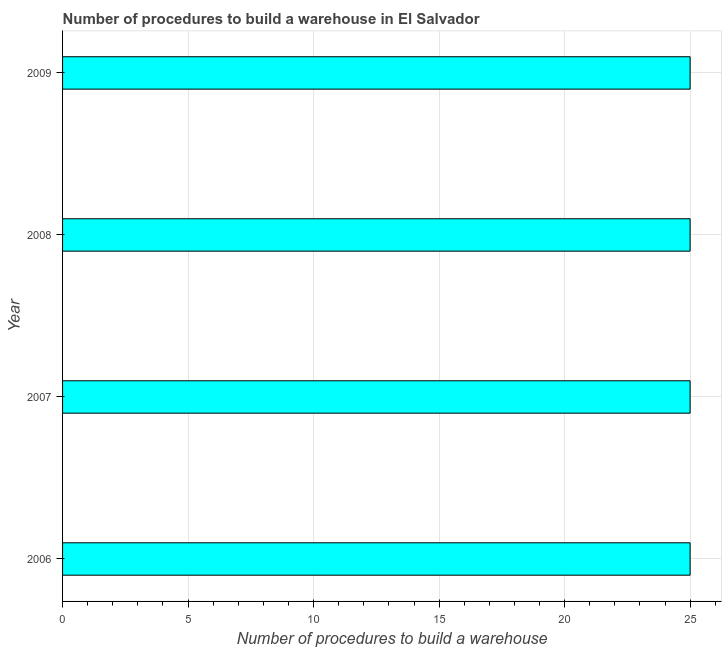Does the graph contain grids?
Your response must be concise. Yes. What is the title of the graph?
Give a very brief answer. Number of procedures to build a warehouse in El Salvador. What is the label or title of the X-axis?
Your response must be concise. Number of procedures to build a warehouse. What is the label or title of the Y-axis?
Offer a very short reply. Year. In which year was the number of procedures to build a warehouse maximum?
Your response must be concise. 2006. In which year was the number of procedures to build a warehouse minimum?
Provide a short and direct response. 2006. Do a majority of the years between 2006 and 2007 (inclusive) have number of procedures to build a warehouse greater than 19 ?
Offer a very short reply. Yes. Is the number of procedures to build a warehouse in 2008 less than that in 2009?
Provide a succinct answer. No. Is the difference between the number of procedures to build a warehouse in 2007 and 2009 greater than the difference between any two years?
Keep it short and to the point. Yes. Is the sum of the number of procedures to build a warehouse in 2006 and 2007 greater than the maximum number of procedures to build a warehouse across all years?
Offer a terse response. Yes. Are all the bars in the graph horizontal?
Provide a short and direct response. Yes. How many years are there in the graph?
Keep it short and to the point. 4. Are the values on the major ticks of X-axis written in scientific E-notation?
Your answer should be very brief. No. What is the Number of procedures to build a warehouse of 2008?
Offer a terse response. 25. What is the difference between the Number of procedures to build a warehouse in 2006 and 2008?
Keep it short and to the point. 0. What is the difference between the Number of procedures to build a warehouse in 2007 and 2008?
Provide a succinct answer. 0. What is the ratio of the Number of procedures to build a warehouse in 2006 to that in 2007?
Give a very brief answer. 1. What is the ratio of the Number of procedures to build a warehouse in 2006 to that in 2008?
Give a very brief answer. 1. What is the ratio of the Number of procedures to build a warehouse in 2008 to that in 2009?
Ensure brevity in your answer.  1. 